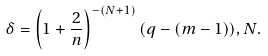<formula> <loc_0><loc_0><loc_500><loc_500>\delta = \left ( 1 + \frac { 2 } { n } \right ) ^ { - ( N + 1 ) } ( q - ( m - 1 ) ) , N .</formula> 